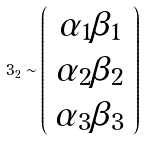<formula> <loc_0><loc_0><loc_500><loc_500>3 _ { 2 } \sim \left ( \begin{array} { c } \alpha _ { 1 } \beta _ { 1 } \\ \alpha _ { 2 } \beta _ { 2 } \\ \alpha _ { 3 } \beta _ { 3 } \end{array} \right )</formula> 